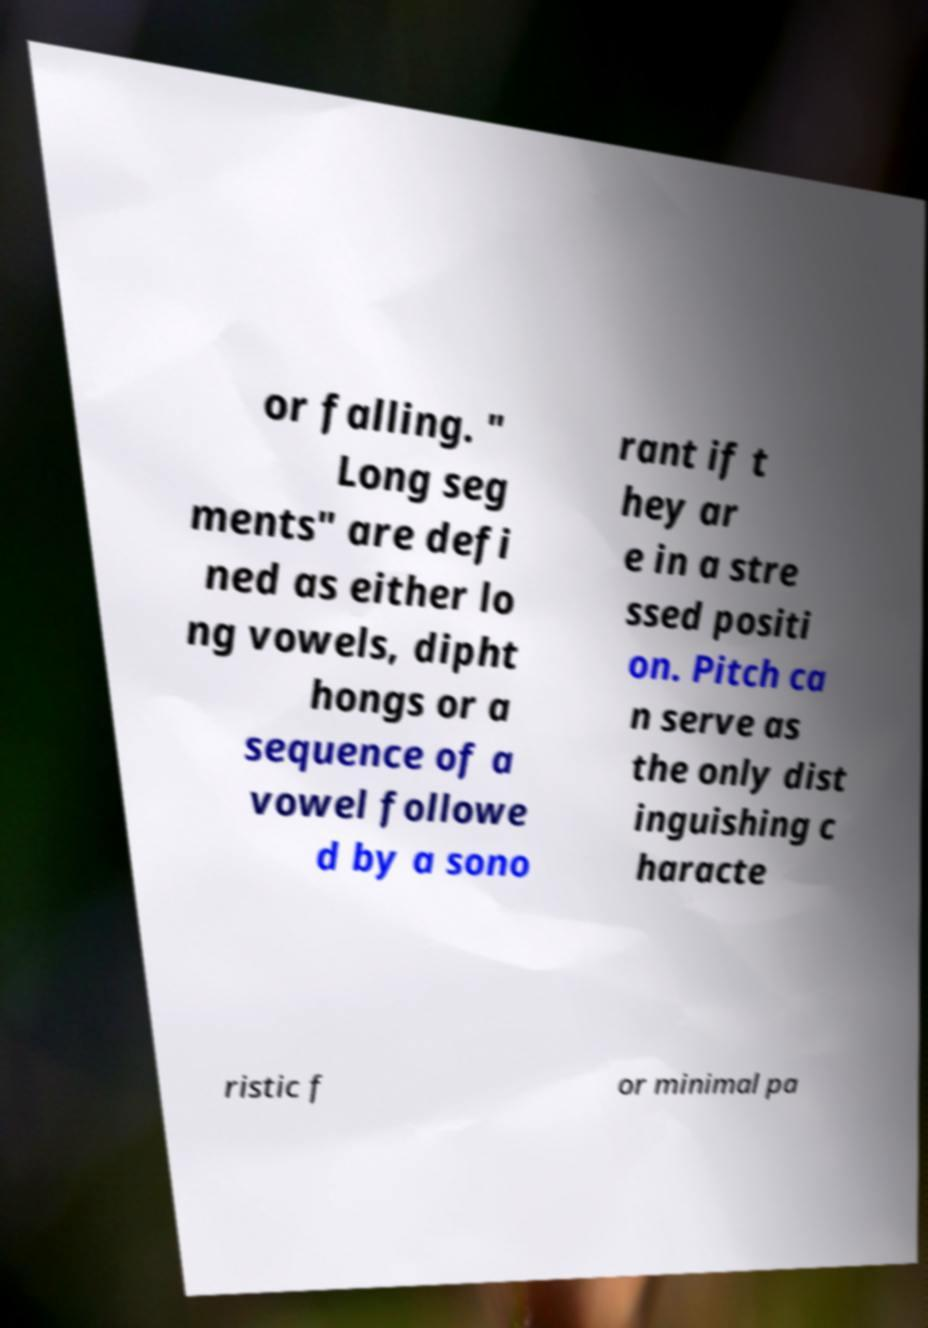Please read and relay the text visible in this image. What does it say? or falling. " Long seg ments" are defi ned as either lo ng vowels, dipht hongs or a sequence of a vowel followe d by a sono rant if t hey ar e in a stre ssed positi on. Pitch ca n serve as the only dist inguishing c haracte ristic f or minimal pa 